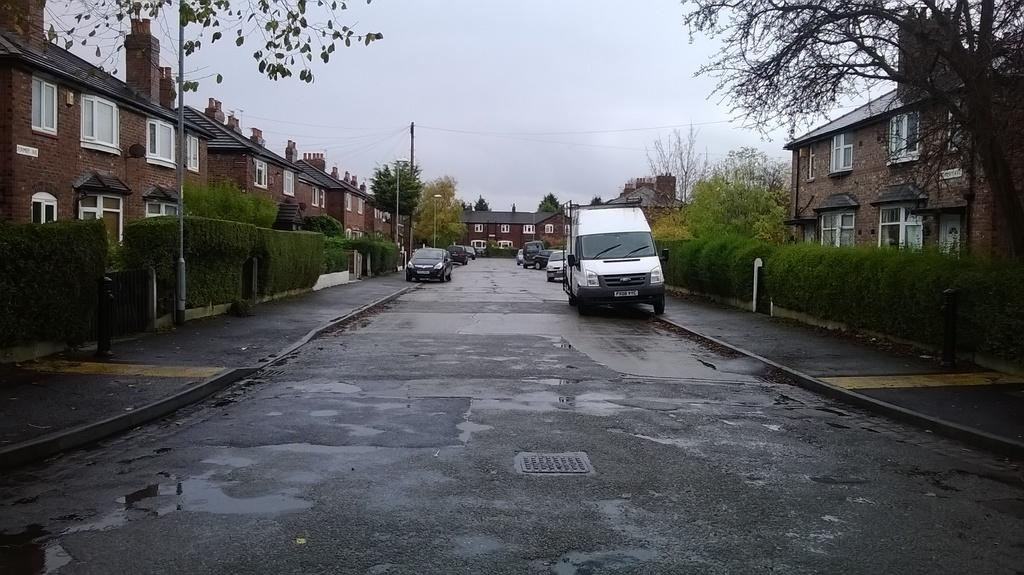What can be seen on the road in the image? There are vehicles on the road in the image. What type of path is present for pedestrians? There are footpaths in the image. What type of vegetation is present in the image? There are trees in the image. What type of structures can be seen in the image? There are buildings with windows in the image. What type of vertical structures are present in the image? There are poles in the image. What is visible in the background of the image? The sky is visible in the background of the image. How many hens are sitting on the poles in the image? There are no hens present in the image; it features vehicles, footpaths, trees, buildings, and poles. What is the income of the person walking on the footpath in the image? There is no information about the income of any person in the image, as it only shows vehicles, footpaths, trees, buildings, and poles. 